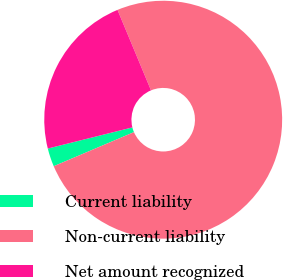<chart> <loc_0><loc_0><loc_500><loc_500><pie_chart><fcel>Current liability<fcel>Non-current liability<fcel>Net amount recognized<nl><fcel>2.5%<fcel>74.88%<fcel>22.62%<nl></chart> 